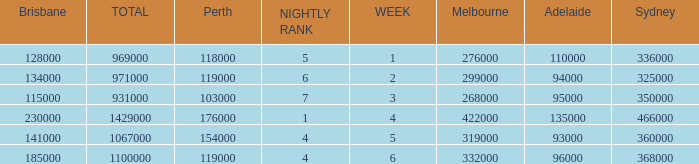What was the rating for Brisbane the week that Adelaide had 94000? 134000.0. Could you parse the entire table? {'header': ['Brisbane', 'TOTAL', 'Perth', 'NIGHTLY RANK', 'WEEK', 'Melbourne', 'Adelaide', 'Sydney'], 'rows': [['128000', '969000', '118000', '5', '1', '276000', '110000', '336000'], ['134000', '971000', '119000', '6', '2', '299000', '94000', '325000'], ['115000', '931000', '103000', '7', '3', '268000', '95000', '350000'], ['230000', '1429000', '176000', '1', '4', '422000', '135000', '466000'], ['141000', '1067000', '154000', '4', '5', '319000', '93000', '360000'], ['185000', '1100000', '119000', '4', '6', '332000', '96000', '368000']]} 